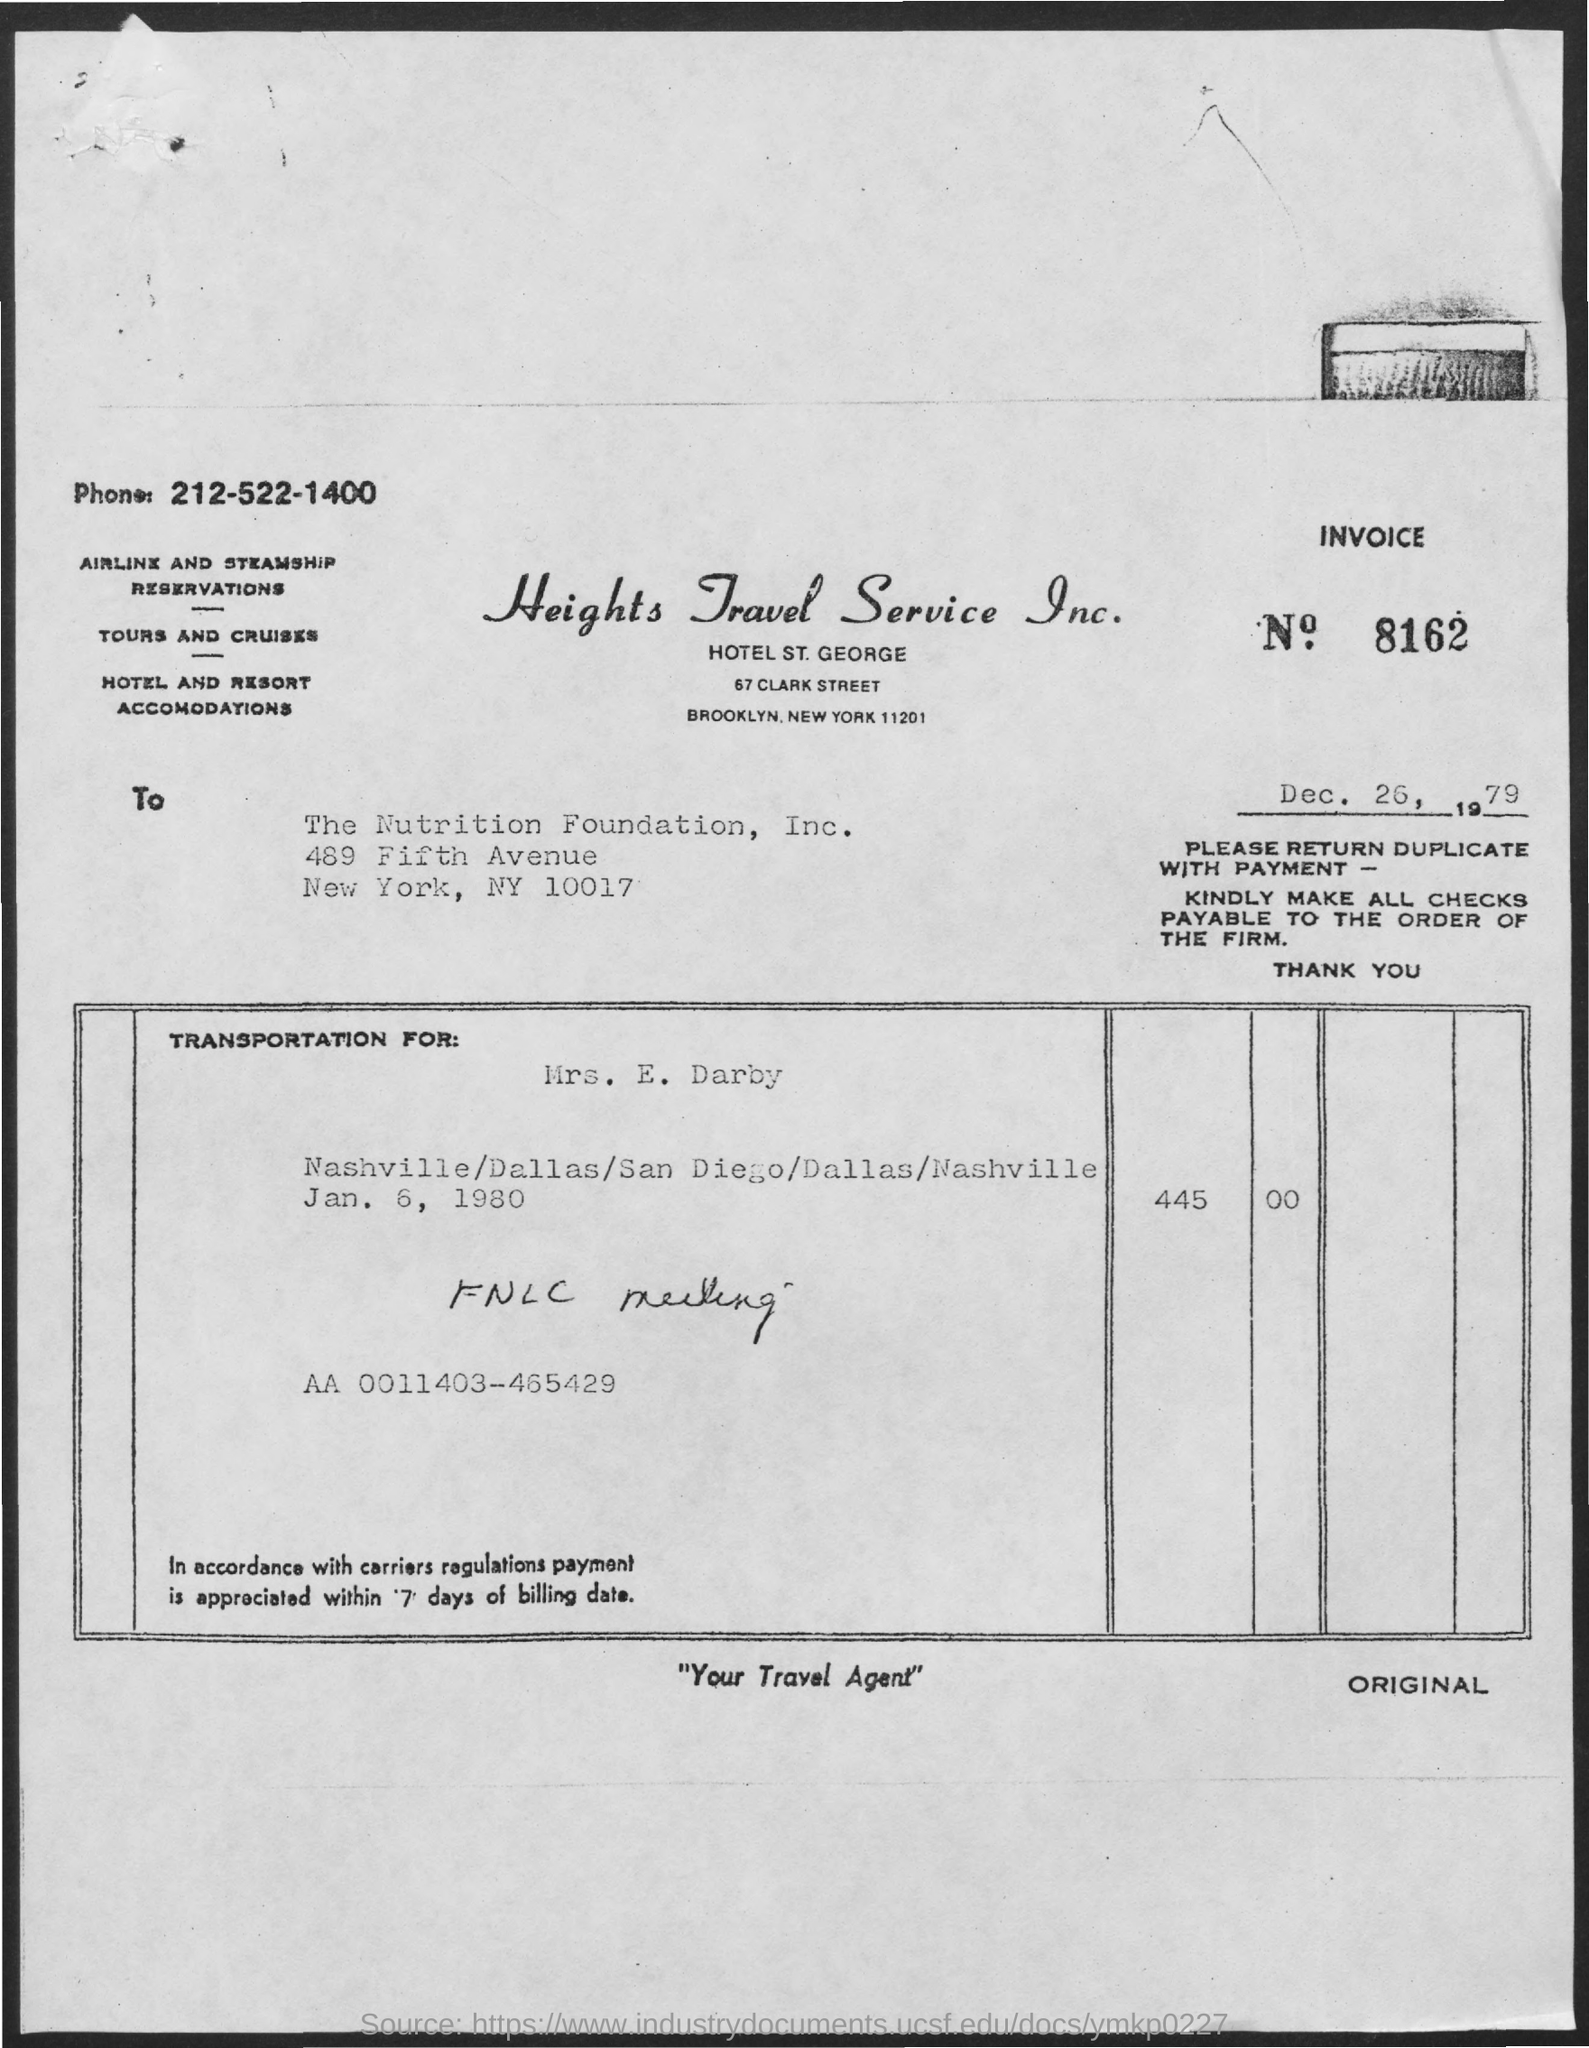List a handful of essential elements in this visual. What is the invoice number mentioned in this document? It is 8162.. The issued date of the invoice is December 26, 1979. The invoice is addressed to The Nutrition Foundation, Inc. The phone number mentioned in this document is 212-522-1400. 